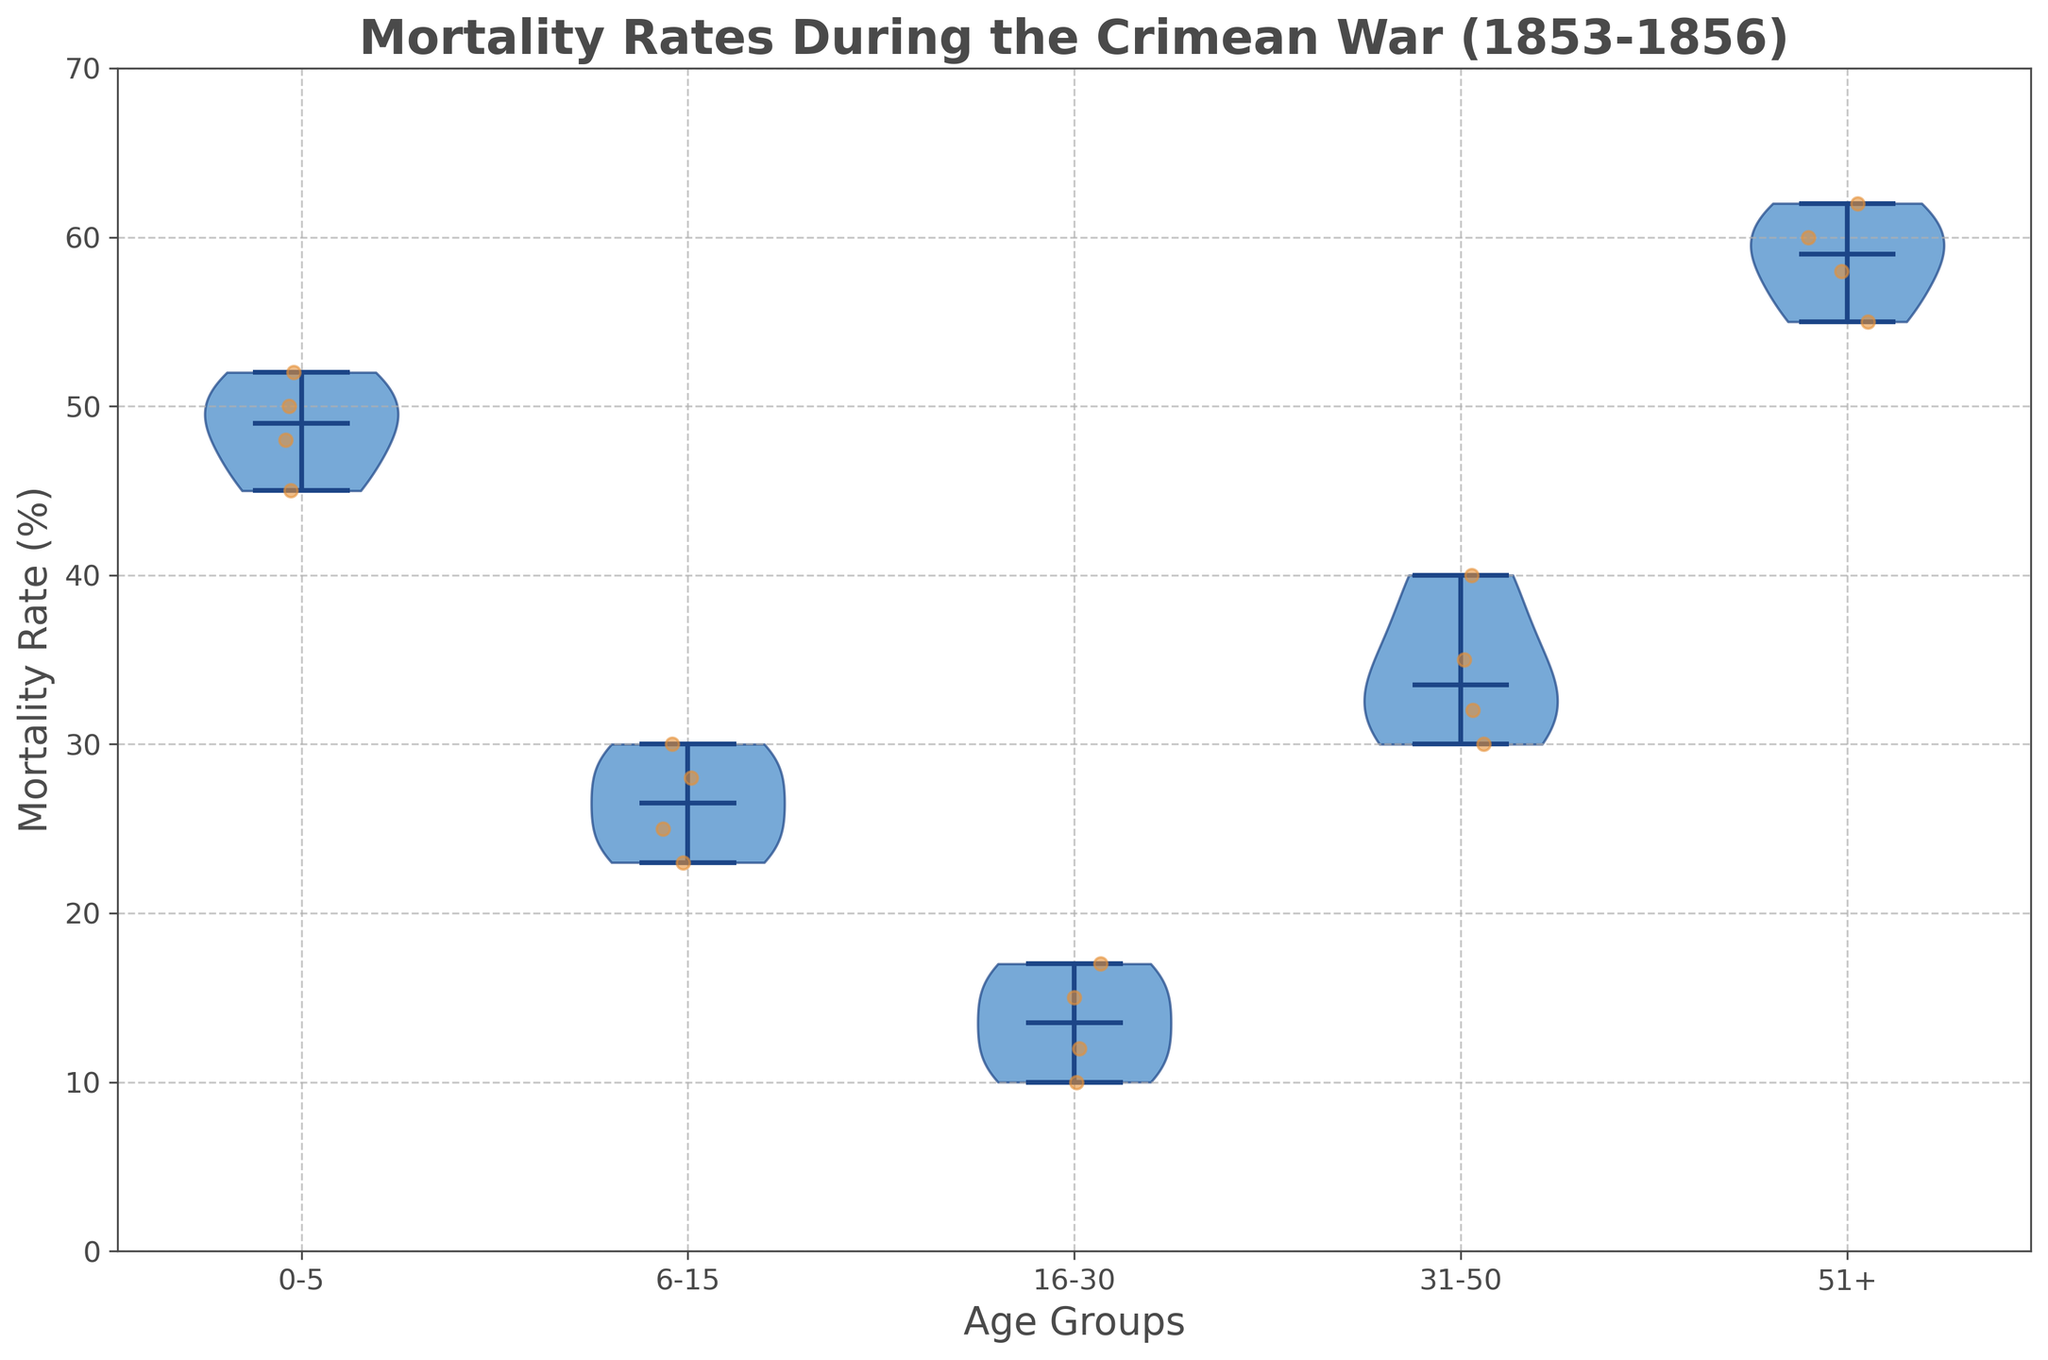What is the title of the figure? The title is typically located at the top of a plot and provides a succinct description of what the plot represents. In this figure, the title is written at the top and reads 'Mortality Rates During the Crimean War (1853-1856)'.
Answer: Mortality Rates During the Crimean War (1853-1856) What are the labels on the axes? The x-axis label, located below the horizontal axis, describes the categories being represented. The y-axis label, located on the left of the vertical axis, describes the measurement being shown. In this plot, the x-axis label is 'Age Groups' and the y-axis label is 'Mortality Rate (%)'.
Answer: Age Groups and Mortality Rate (%) Which age group has the highest median mortality rate? Medians in violin plots are typically indicated by a distinct line within the shape. By looking for the line's position within each age group, we can determine which one is highest. In this case, the age group '51+' has the highest median mortality rate.
Answer: 51+ Compare the mortality rates of age groups 0-5 and 16-30. Which group has the larger spread? The spread of a distribution in a violin plot is indicated by the width of the shape; a wider shape indicates more variability. The violin for age group 0-5 is visibly wider compared to the age group 16-30, indicating a larger spread.
Answer: 0-5 What is the approximate median mortality rate for the 6-15 age group? The median is marked by a horizontal line inside each violin. For the 6-15 age group, this line is around the point slightly above 25%.
Answer: Slightly above 25% Which age group has the smallest range of mortality rates? The range in a violin plot is indicated by the height of the shape. The smaller the height, the smaller the range. The age group '16-30' shows the smallest range based on the height of its violin shape.
Answer: 16-30 Are there any age groups where the mortality rate range exceeds 10 percentage points? Examining the height of each violin shape, we can see that both '0-5' and '51+' age groups have shapes that extend beyond 10 percentage points from top to bottom.
Answer: Yes, 0-5 and 51+ Which age group has a median closer to the lower end of its range? By observing the position of the median line within each violin shape, '16-30' has its median closer to the bottom edge indicating it is nearer to the lower end of its range.
Answer: 16-30 What is the color of the dots that represent individual data points? The dots on the plot that individually mark mortality rate data points are colored noticeably. These points are colored in a warm tone, which is orange.
Answer: Orange 